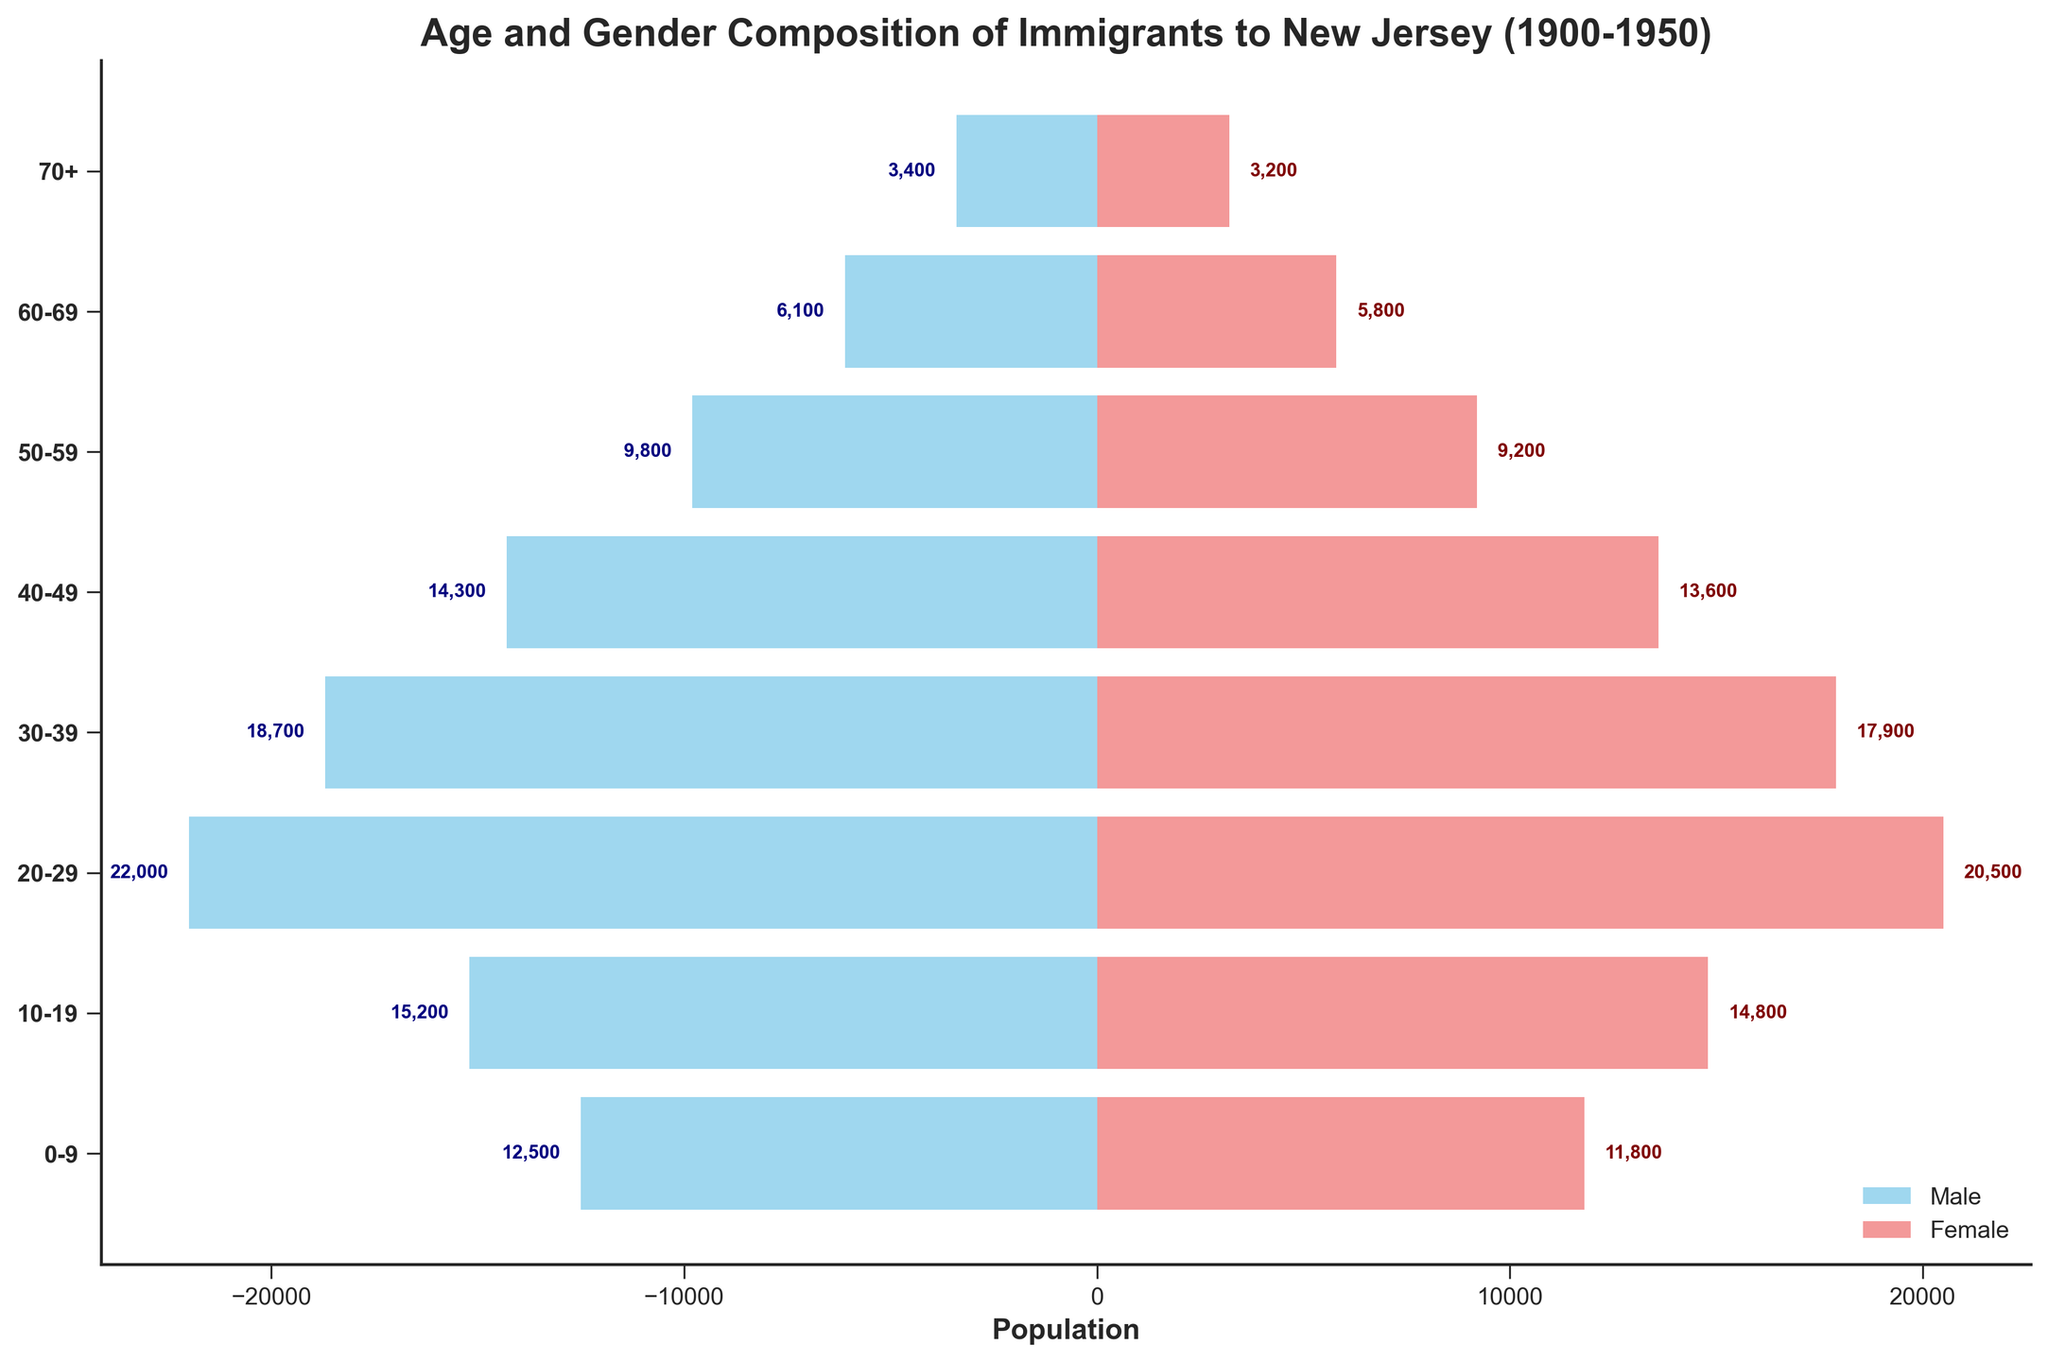What is the title of the figure? The title is typically found at the top of the figure, indicating what the visual represents.
Answer: Age and Gender Composition of Immigrants to New Jersey (1900-1950) What color represents the male population? The color used for males can be identified by looking at the legend provided in the figure.
Answer: Sky blue How many age groups are represented in the figure? The number of age groups can be counted by looking at the y-axis labels.
Answer: 8 Which age group has the highest male immigrant population? You can identify the highest male immigrant population by finding the longest sky blue bar extending left from the center.
Answer: 20-29 What's the total population of immigrants aged 0-29? Add the values for both males and females in the age groups 0-9, 10-19, and 20-29. For 0-9: 12500 + 11800, for 10-19: 15200 + 14800, for 20-29: 22000 + 20500; then sum these totals.
Answer: 106800 What is the difference in the population between males and females in the 30-39 age group? Subtract the female population from the male population for the 30-39 age group (18700 - 17900).
Answer: 800 Which gender has more immigrants aged 70+? Compare the lengths of the bars for the male and female populations in the 70+ age group and see which one is longer.
Answer: Males How does the population of females aged 20-29 compare to that of males aged 50-59? Compare the length of the light coral bar for the 20-29 female group (20500) with the length of the sky blue bar for the 50-59 male group (9800).
Answer: Females aged 20-29 have more immigrants than males aged 50-59 What is the average population of female immigrants in the age groups 30-39 and 40-49? Add the female populations for the age groups 30-39 and 40-49, then divide by 2 ((17900 + 13600) / 2).
Answer: 15750 Which age group shows the closest population between males and females? Look for the age group where the values for males and females are most similar and have the smallest numerical difference.
Answer: 30-39 